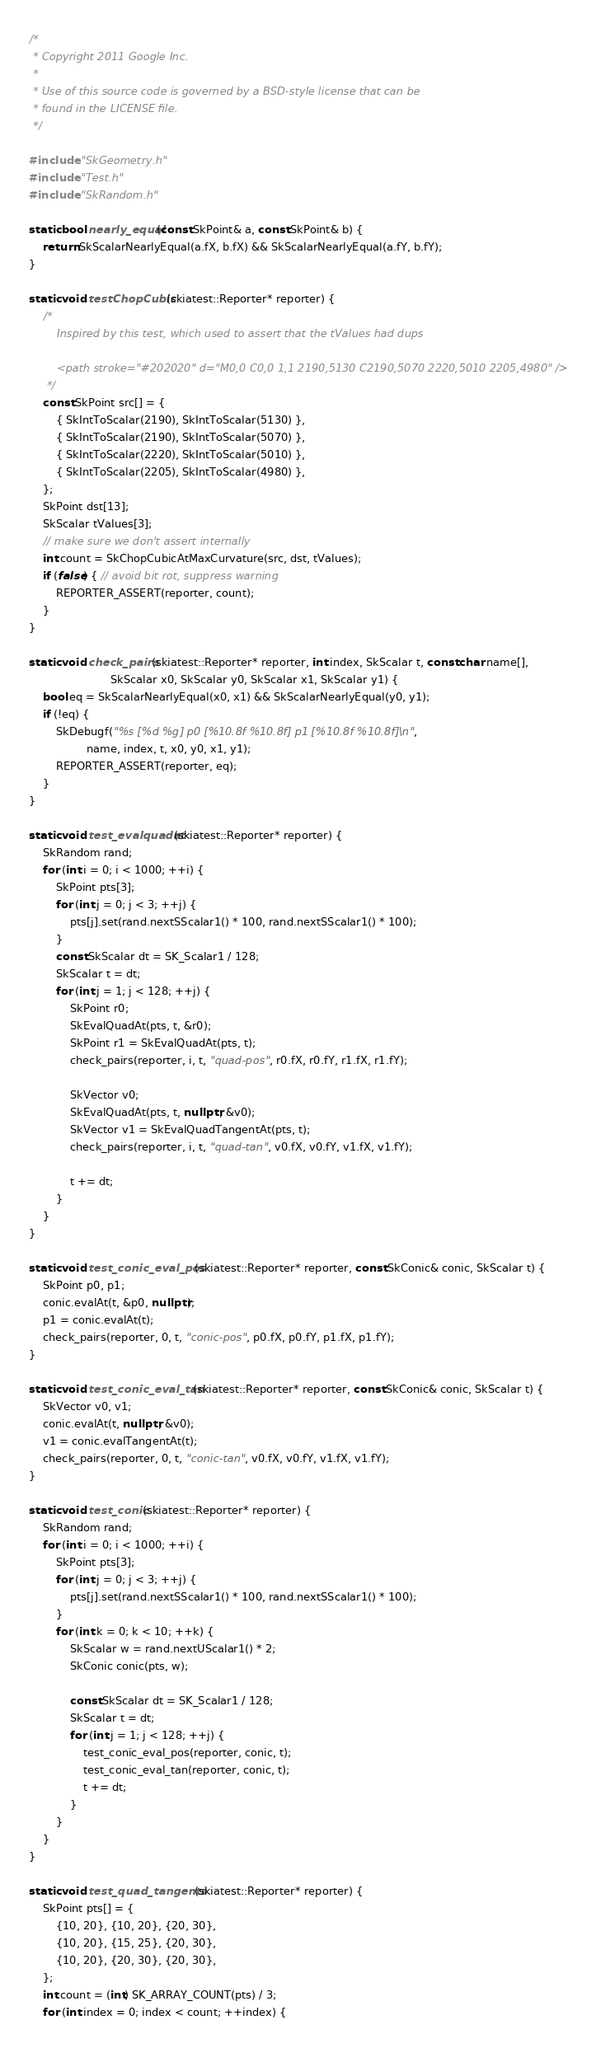Convert code to text. <code><loc_0><loc_0><loc_500><loc_500><_C++_>/*
 * Copyright 2011 Google Inc.
 *
 * Use of this source code is governed by a BSD-style license that can be
 * found in the LICENSE file.
 */

#include "SkGeometry.h"
#include "Test.h"
#include "SkRandom.h"

static bool nearly_equal(const SkPoint& a, const SkPoint& b) {
    return SkScalarNearlyEqual(a.fX, b.fX) && SkScalarNearlyEqual(a.fY, b.fY);
}

static void testChopCubic(skiatest::Reporter* reporter) {
    /*
        Inspired by this test, which used to assert that the tValues had dups

        <path stroke="#202020" d="M0,0 C0,0 1,1 2190,5130 C2190,5070 2220,5010 2205,4980" />
     */
    const SkPoint src[] = {
        { SkIntToScalar(2190), SkIntToScalar(5130) },
        { SkIntToScalar(2190), SkIntToScalar(5070) },
        { SkIntToScalar(2220), SkIntToScalar(5010) },
        { SkIntToScalar(2205), SkIntToScalar(4980) },
    };
    SkPoint dst[13];
    SkScalar tValues[3];
    // make sure we don't assert internally
    int count = SkChopCubicAtMaxCurvature(src, dst, tValues);
    if (false) { // avoid bit rot, suppress warning
        REPORTER_ASSERT(reporter, count);
    }
}

static void check_pairs(skiatest::Reporter* reporter, int index, SkScalar t, const char name[],
                        SkScalar x0, SkScalar y0, SkScalar x1, SkScalar y1) {
    bool eq = SkScalarNearlyEqual(x0, x1) && SkScalarNearlyEqual(y0, y1);
    if (!eq) {
        SkDebugf("%s [%d %g] p0 [%10.8f %10.8f] p1 [%10.8f %10.8f]\n",
                 name, index, t, x0, y0, x1, y1);
        REPORTER_ASSERT(reporter, eq);
    }
}

static void test_evalquadat(skiatest::Reporter* reporter) {
    SkRandom rand;
    for (int i = 0; i < 1000; ++i) {
        SkPoint pts[3];
        for (int j = 0; j < 3; ++j) {
            pts[j].set(rand.nextSScalar1() * 100, rand.nextSScalar1() * 100);
        }
        const SkScalar dt = SK_Scalar1 / 128;
        SkScalar t = dt;
        for (int j = 1; j < 128; ++j) {
            SkPoint r0;
            SkEvalQuadAt(pts, t, &r0);
            SkPoint r1 = SkEvalQuadAt(pts, t);
            check_pairs(reporter, i, t, "quad-pos", r0.fX, r0.fY, r1.fX, r1.fY);

            SkVector v0;
            SkEvalQuadAt(pts, t, nullptr, &v0);
            SkVector v1 = SkEvalQuadTangentAt(pts, t);
            check_pairs(reporter, i, t, "quad-tan", v0.fX, v0.fY, v1.fX, v1.fY);

            t += dt;
        }
    }
}

static void test_conic_eval_pos(skiatest::Reporter* reporter, const SkConic& conic, SkScalar t) {
    SkPoint p0, p1;
    conic.evalAt(t, &p0, nullptr);
    p1 = conic.evalAt(t);
    check_pairs(reporter, 0, t, "conic-pos", p0.fX, p0.fY, p1.fX, p1.fY);
}

static void test_conic_eval_tan(skiatest::Reporter* reporter, const SkConic& conic, SkScalar t) {
    SkVector v0, v1;
    conic.evalAt(t, nullptr, &v0);
    v1 = conic.evalTangentAt(t);
    check_pairs(reporter, 0, t, "conic-tan", v0.fX, v0.fY, v1.fX, v1.fY);
}

static void test_conic(skiatest::Reporter* reporter) {
    SkRandom rand;
    for (int i = 0; i < 1000; ++i) {
        SkPoint pts[3];
        for (int j = 0; j < 3; ++j) {
            pts[j].set(rand.nextSScalar1() * 100, rand.nextSScalar1() * 100);
        }
        for (int k = 0; k < 10; ++k) {
            SkScalar w = rand.nextUScalar1() * 2;
            SkConic conic(pts, w);

            const SkScalar dt = SK_Scalar1 / 128;
            SkScalar t = dt;
            for (int j = 1; j < 128; ++j) {
                test_conic_eval_pos(reporter, conic, t);
                test_conic_eval_tan(reporter, conic, t);
                t += dt;
            }
        }
    }
}

static void test_quad_tangents(skiatest::Reporter* reporter) {
    SkPoint pts[] = {
        {10, 20}, {10, 20}, {20, 30},
        {10, 20}, {15, 25}, {20, 30},
        {10, 20}, {20, 30}, {20, 30},
    };
    int count = (int) SK_ARRAY_COUNT(pts) / 3;
    for (int index = 0; index < count; ++index) {</code> 